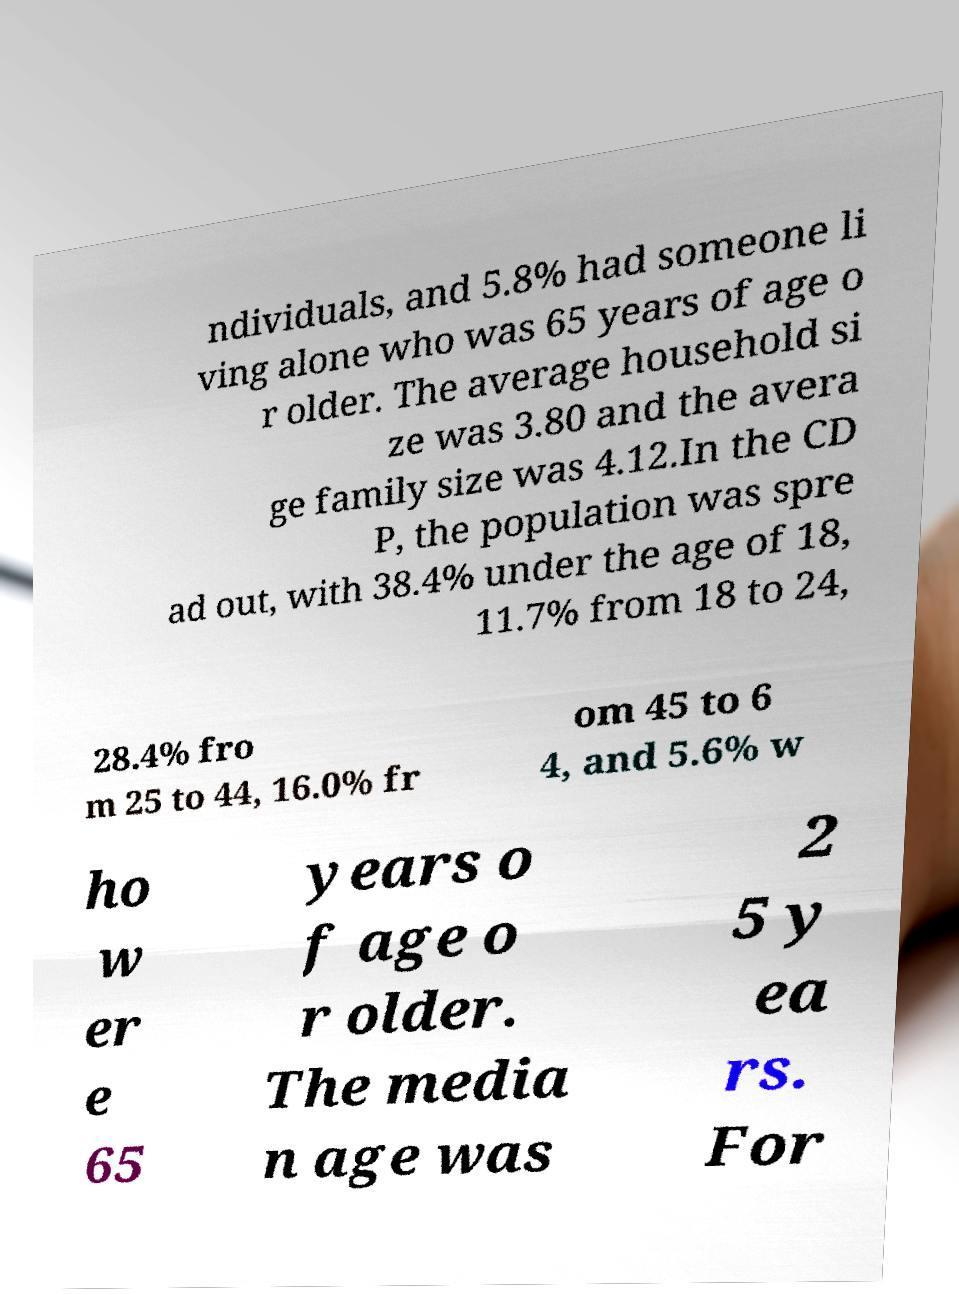There's text embedded in this image that I need extracted. Can you transcribe it verbatim? ndividuals, and 5.8% had someone li ving alone who was 65 years of age o r older. The average household si ze was 3.80 and the avera ge family size was 4.12.In the CD P, the population was spre ad out, with 38.4% under the age of 18, 11.7% from 18 to 24, 28.4% fro m 25 to 44, 16.0% fr om 45 to 6 4, and 5.6% w ho w er e 65 years o f age o r older. The media n age was 2 5 y ea rs. For 